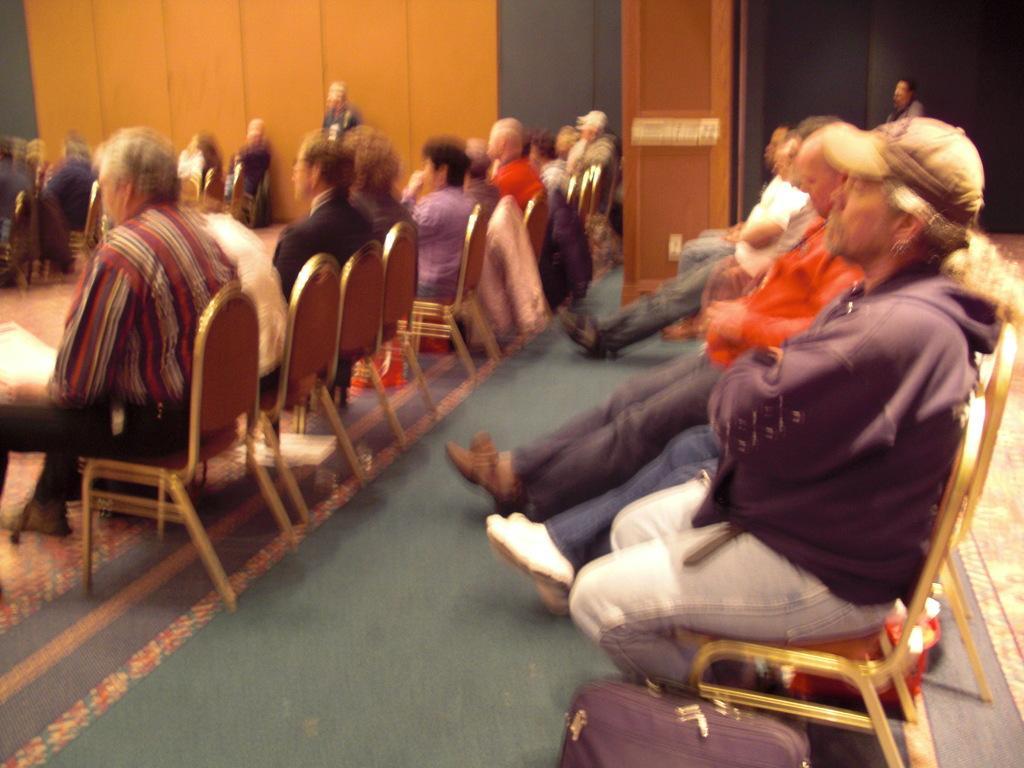Could you give a brief overview of what you see in this image? In a room there are many people sitting on a chairs. And to the bottom there is a bag. And we can see a pillar. 